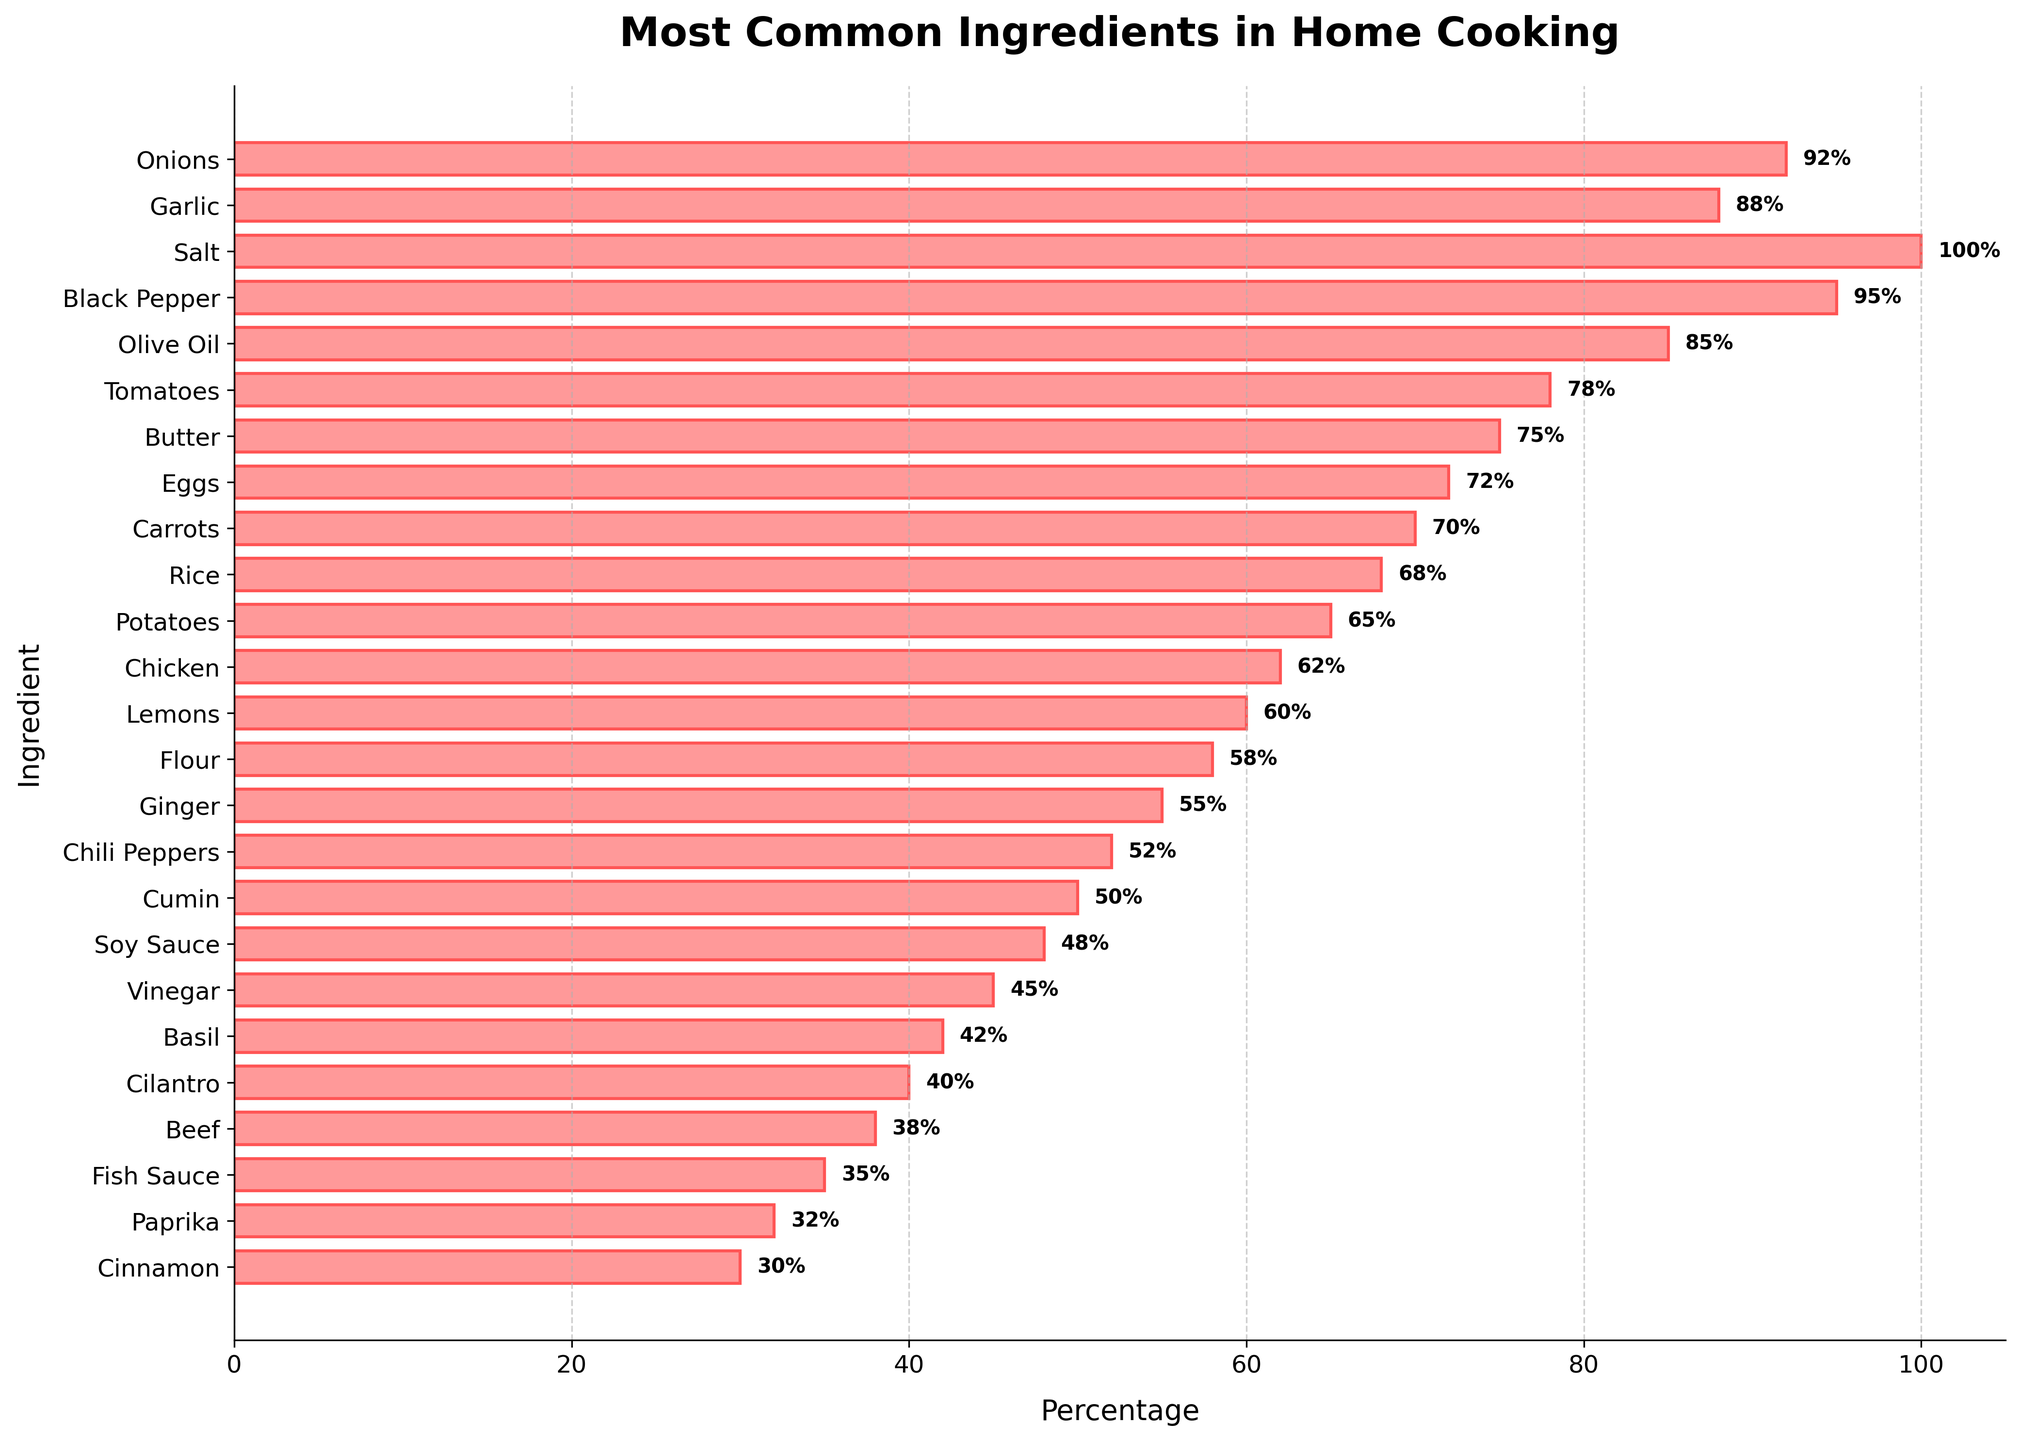Which ingredient has the highest percentage of usage in home cooking? The ingredient with the highest percentage is easily identified by looking at the length of the bar that extends the furthest to the right. In this case, it is the bar for "Salt".
Answer: Salt What is the difference in percentage usage between Black Pepper and Garlic? To find the difference, look at the percentage for Black Pepper (95%) and subtract the percentage for Garlic (88%). The calculation is 95% - 88%.
Answer: 7% How many ingredients have a percentage usage of over 80%? Identify the bars that have values greater than 80%. The ingredients with over 80% usage are Onions, Garlic, Salt, Black Pepper, and Olive Oil.
Answer: 5 Is the usage percentage of Carrots higher than that of Rice? Compare the percentage values of Carrots and Rice. Carrots have a percentage of 70%, whereas Rice has a percentage of 68%.
Answer: Yes What is the total percentage usage of the top 3 most common ingredients? The top three ingredients by usage percentage are Salt (100%), Black Pepper (95%), and Onions (92%). Sum these percentages: 100% + 95% + 92%.
Answer: 287% Which ingredient has the lowest percentage usage? Look for the shortest bar in the bar chart. The ingredient at the bottom of the list with the smallest percentage is Cinnamon.
Answer: Cinnamon By how much does the percentage usage of Tomatoes exceed that of Chicken? Identify the percentage values: Tomatoes (78%) and Chicken (62%). Subtract the smaller value from the larger: 78% - 62%.
Answer: 16% If you average the percentage usage of Eggs, Carrots, and Rice, what is the result? Sum the percentages of Eggs (72%), Carrots (70%), and Rice (68%). Then divide by 3 to find the average: (72% + 70% + 68%) / 3.
Answer: 70% Are there more ingredients with a percentage usage above 50% or below 50%? Count the number of ingredients above 50% and compare it to the count below 50%. Ingredients above 50%: 15, and below 50%: 10.
Answer: Above 50% What color are the bars representing the ingredients in the bar chart? The bars representing the percentages are colored light red with a darker red edge.
Answer: Light red 